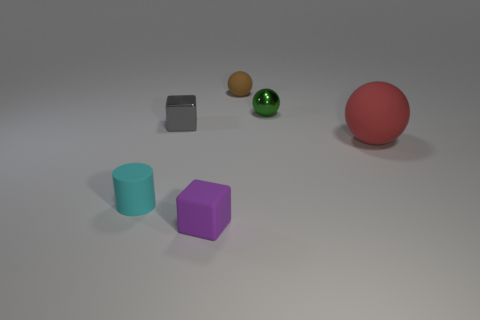Subtract all gray spheres. Subtract all red blocks. How many spheres are left? 3 Add 2 metal balls. How many objects exist? 8 Subtract all cylinders. How many objects are left? 5 Subtract 0 red blocks. How many objects are left? 6 Subtract all large cyan matte cylinders. Subtract all cyan cylinders. How many objects are left? 5 Add 6 big matte objects. How many big matte objects are left? 7 Add 4 red matte spheres. How many red matte spheres exist? 5 